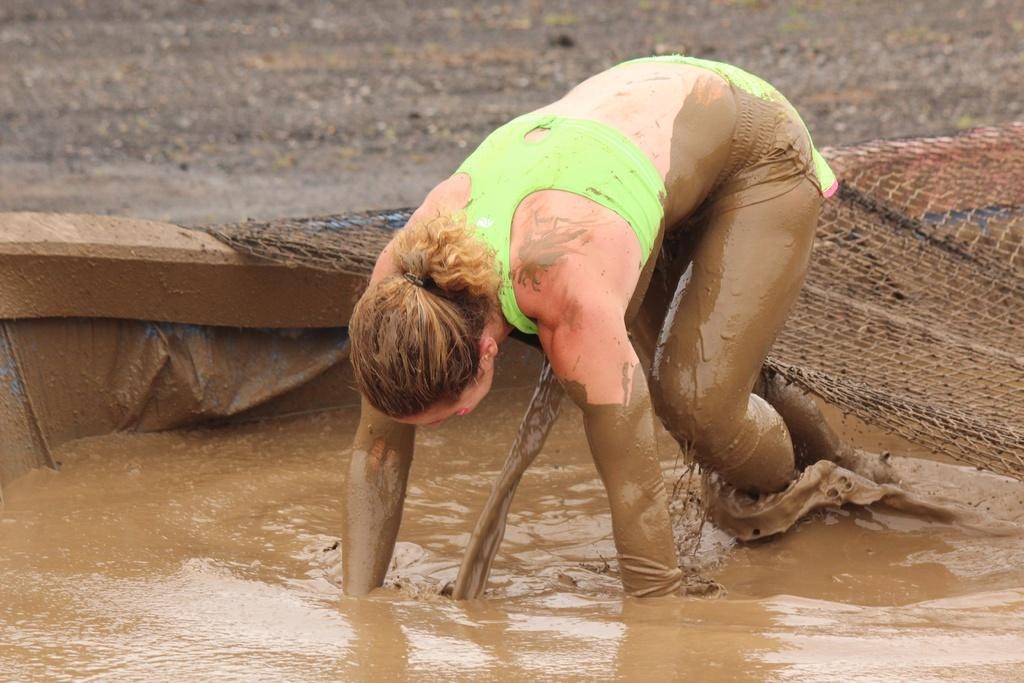Who is present in the image? There is a woman in the image. What is the woman doing in the image? The woman is playing in the mud. What object can be seen in the image, related to sports or games? There is a net in the image. What structure is partially covering the mud in the image? There is a small wall in the image, covering the mud. Can you see an airplane flying in the image? No, there is no airplane present in the image. Is the woman kicking a soccer ball in the image? The image does not show the woman kicking a soccer ball or any other object. 